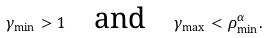<formula> <loc_0><loc_0><loc_500><loc_500>\gamma _ { \min } > 1 \quad \text {and} \quad \gamma _ { \max } < \rho _ { \min } ^ { \alpha } .</formula> 